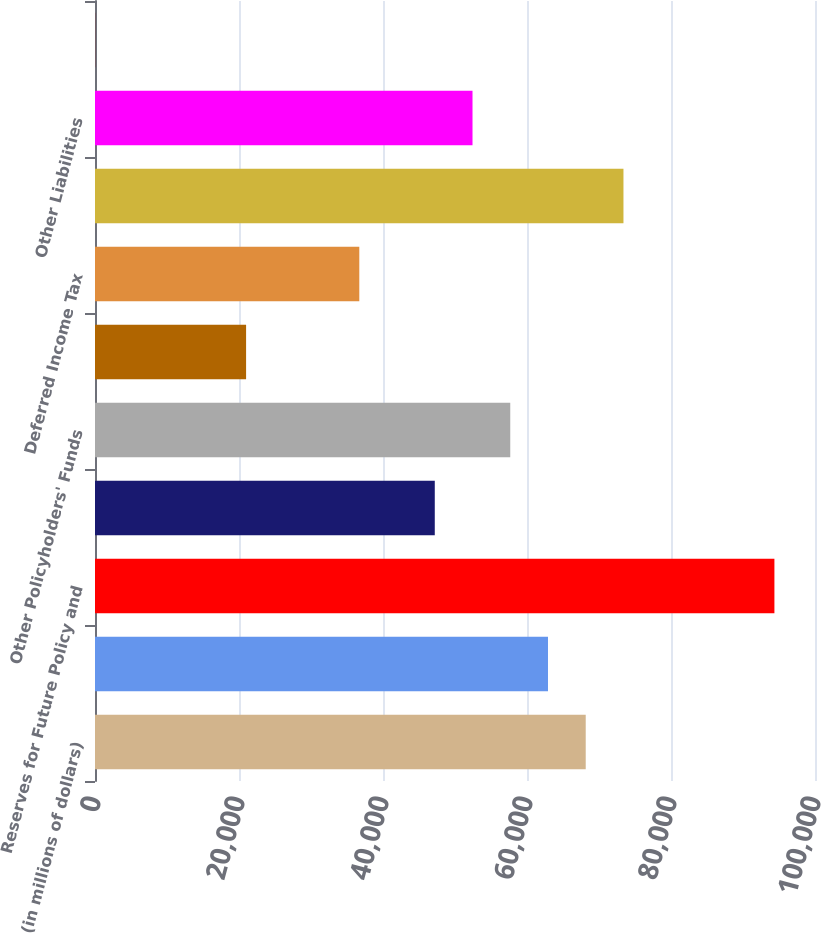Convert chart. <chart><loc_0><loc_0><loc_500><loc_500><bar_chart><fcel>(in millions of dollars)<fcel>Policy and Contract Benefits<fcel>Reserves for Future Policy and<fcel>Unearned Premiums<fcel>Other Policyholders' Funds<fcel>Income Tax Payable<fcel>Deferred Income Tax<fcel>Long-term Debt<fcel>Other Liabilities<fcel>Separate Account Liabilities<nl><fcel>68156.4<fcel>62915.2<fcel>94362.7<fcel>47191.4<fcel>57673.9<fcel>20985.2<fcel>36708.9<fcel>73397.7<fcel>52432.7<fcel>20.2<nl></chart> 